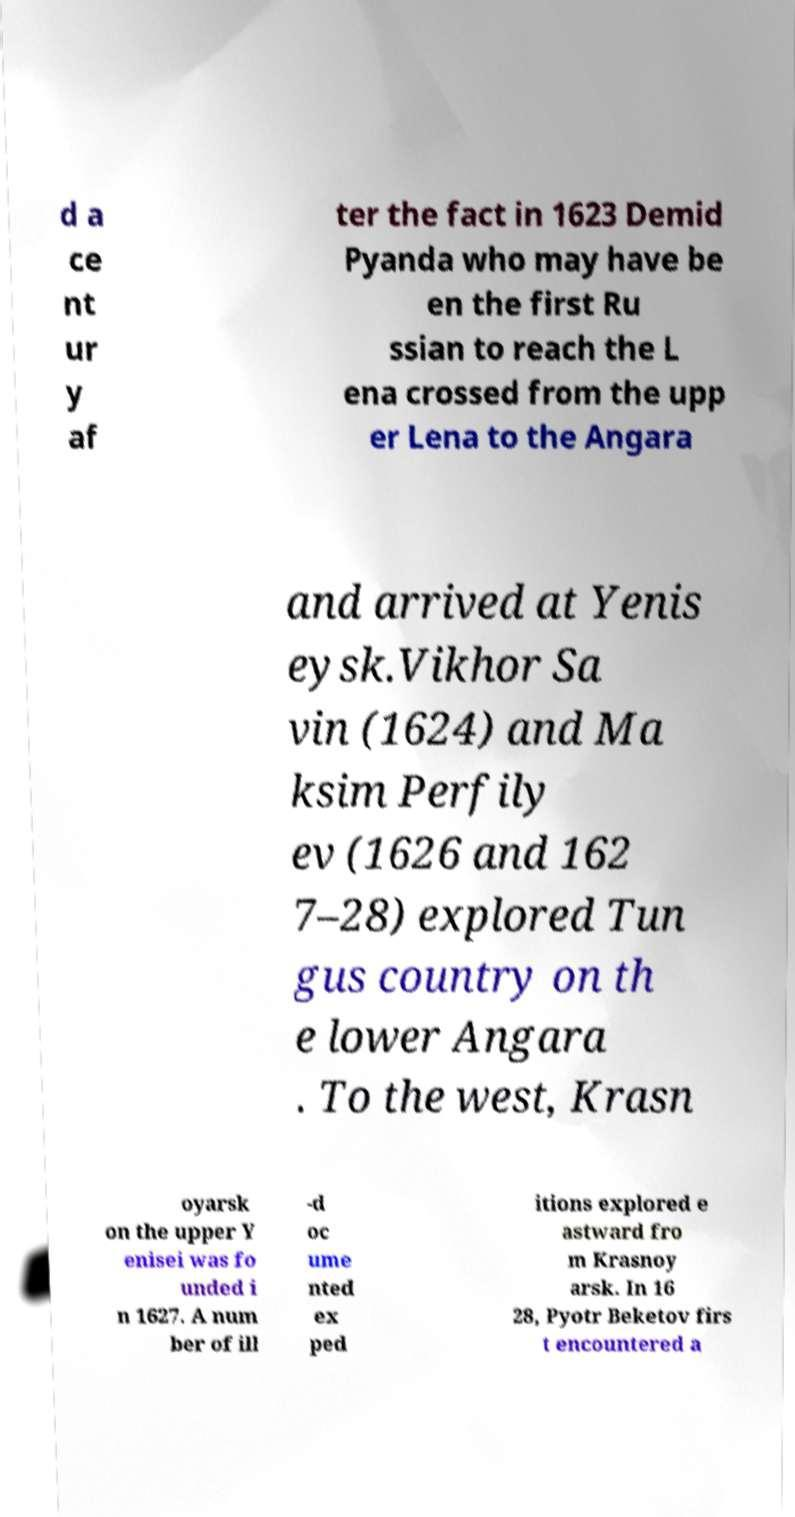Could you assist in decoding the text presented in this image and type it out clearly? d a ce nt ur y af ter the fact in 1623 Demid Pyanda who may have be en the first Ru ssian to reach the L ena crossed from the upp er Lena to the Angara and arrived at Yenis eysk.Vikhor Sa vin (1624) and Ma ksim Perfily ev (1626 and 162 7–28) explored Tun gus country on th e lower Angara . To the west, Krasn oyarsk on the upper Y enisei was fo unded i n 1627. A num ber of ill -d oc ume nted ex ped itions explored e astward fro m Krasnoy arsk. In 16 28, Pyotr Beketov firs t encountered a 